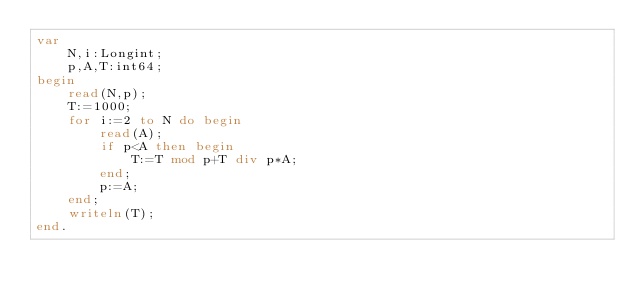<code> <loc_0><loc_0><loc_500><loc_500><_Pascal_>var
	N,i:Longint;
	p,A,T:int64;
begin
	read(N,p);
	T:=1000;
	for i:=2 to N do begin
		read(A);
		if p<A then begin
			T:=T mod p+T div p*A;
		end;
		p:=A;
	end;
	writeln(T);
end.</code> 